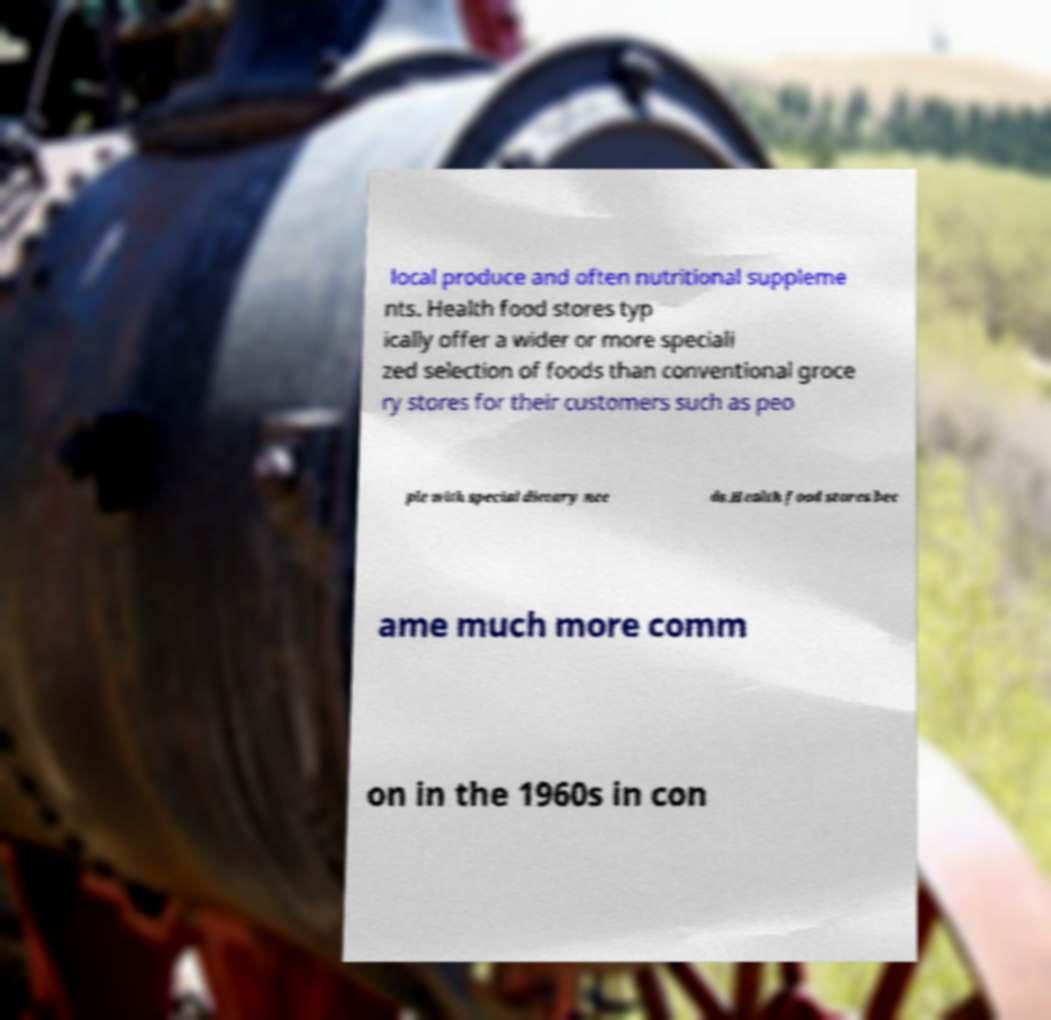What messages or text are displayed in this image? I need them in a readable, typed format. local produce and often nutritional suppleme nts. Health food stores typ ically offer a wider or more speciali zed selection of foods than conventional groce ry stores for their customers such as peo ple with special dietary nee ds.Health food stores bec ame much more comm on in the 1960s in con 